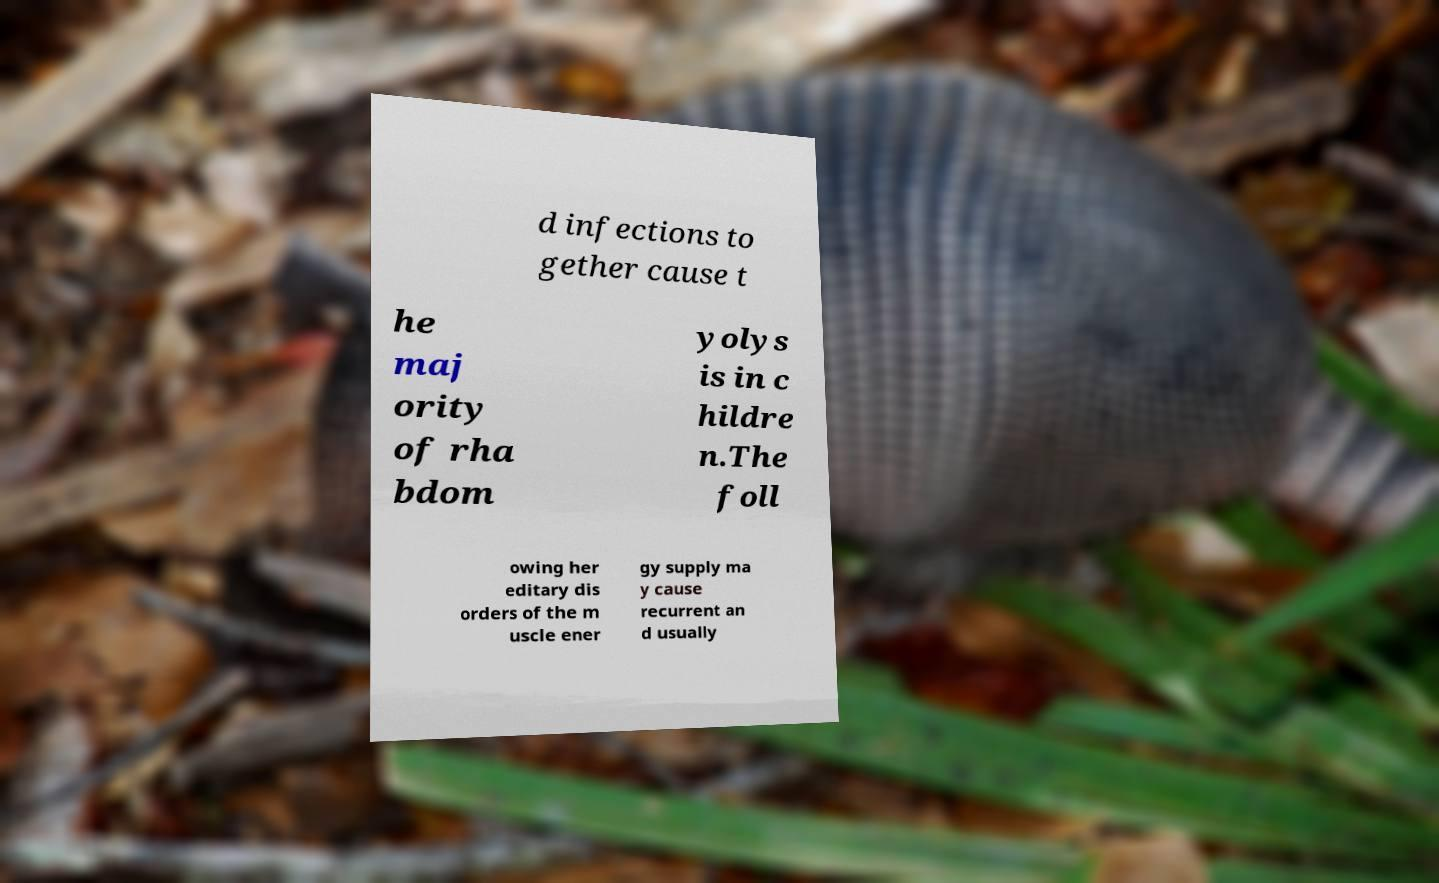Please read and relay the text visible in this image. What does it say? d infections to gether cause t he maj ority of rha bdom yolys is in c hildre n.The foll owing her editary dis orders of the m uscle ener gy supply ma y cause recurrent an d usually 